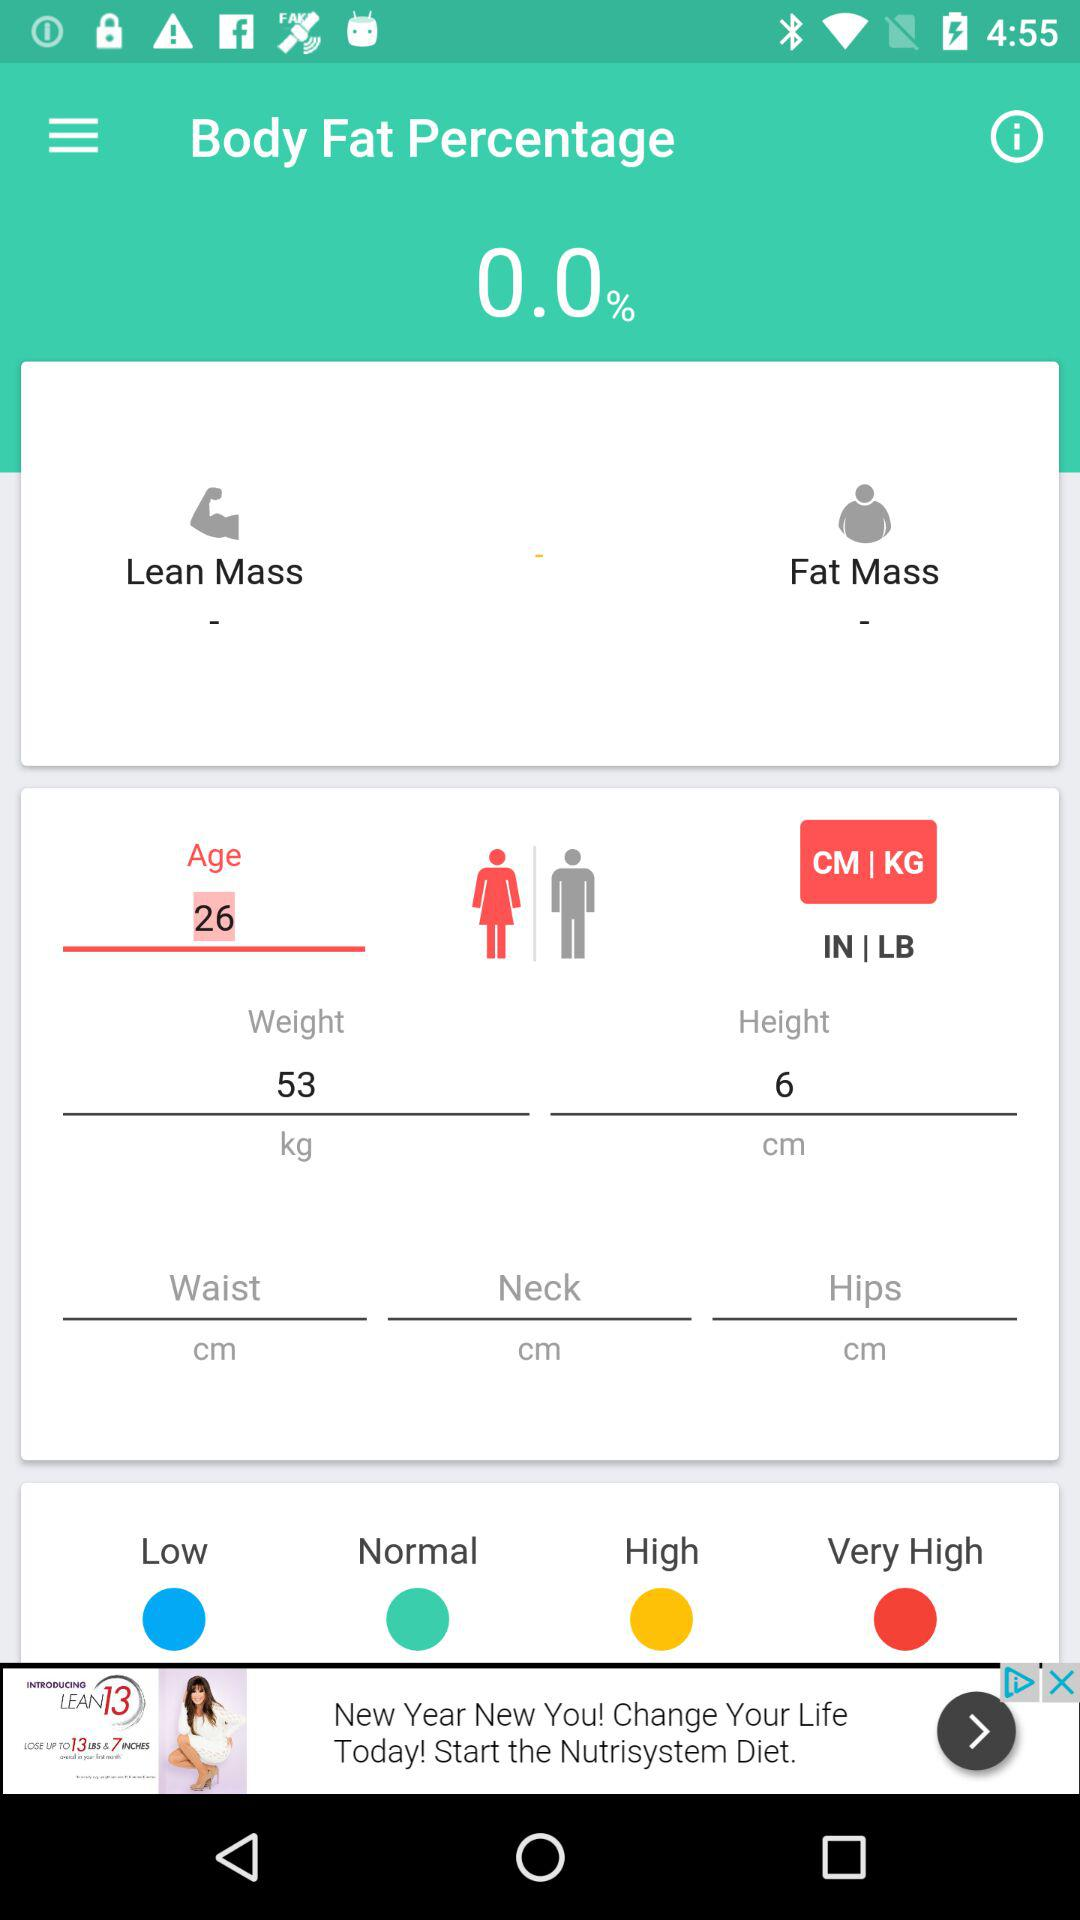When was the body fat percentage calculated?
When the provided information is insufficient, respond with <no answer>. <no answer> 